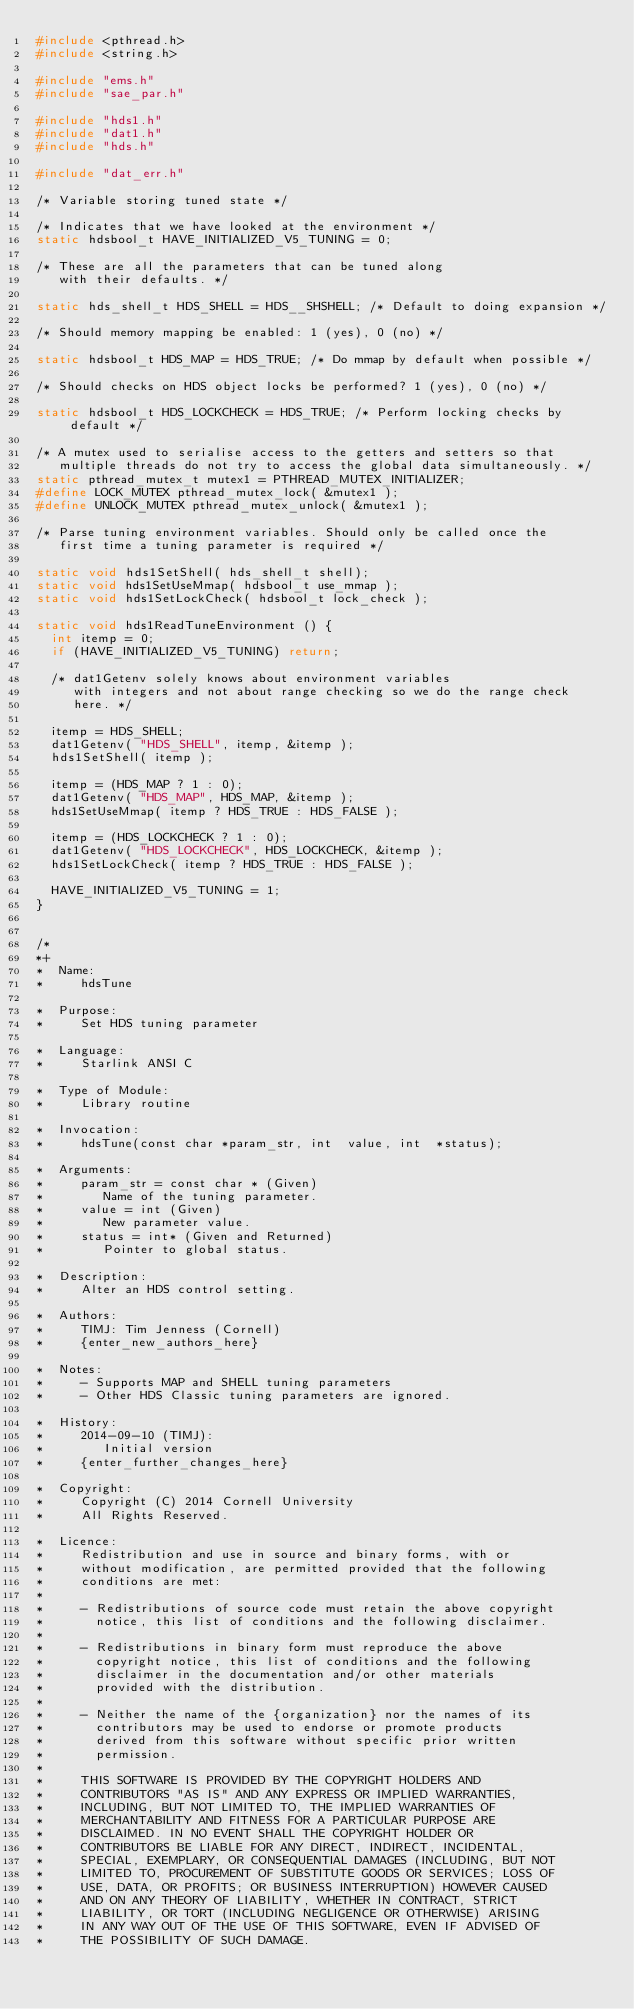Convert code to text. <code><loc_0><loc_0><loc_500><loc_500><_C_>#include <pthread.h>
#include <string.h>

#include "ems.h"
#include "sae_par.h"

#include "hds1.h"
#include "dat1.h"
#include "hds.h"

#include "dat_err.h"

/* Variable storing tuned state */

/* Indicates that we have looked at the environment */
static hdsbool_t HAVE_INITIALIZED_V5_TUNING = 0;

/* These are all the parameters that can be tuned along
   with their defaults. */

static hds_shell_t HDS_SHELL = HDS__SHSHELL; /* Default to doing expansion */

/* Should memory mapping be enabled: 1 (yes), 0 (no) */

static hdsbool_t HDS_MAP = HDS_TRUE; /* Do mmap by default when possible */

/* Should checks on HDS object locks be performed? 1 (yes), 0 (no) */

static hdsbool_t HDS_LOCKCHECK = HDS_TRUE; /* Perform locking checks by default */

/* A mutex used to serialise access to the getters and setters so that
   multiple threads do not try to access the global data simultaneously. */
static pthread_mutex_t mutex1 = PTHREAD_MUTEX_INITIALIZER;
#define LOCK_MUTEX pthread_mutex_lock( &mutex1 );
#define UNLOCK_MUTEX pthread_mutex_unlock( &mutex1 );

/* Parse tuning environment variables. Should only be called once the
   first time a tuning parameter is required */

static void hds1SetShell( hds_shell_t shell);
static void hds1SetUseMmap( hdsbool_t use_mmap );
static void hds1SetLockCheck( hdsbool_t lock_check );

static void hds1ReadTuneEnvironment () {
  int itemp = 0;
  if (HAVE_INITIALIZED_V5_TUNING) return;

  /* dat1Getenv solely knows about environment variables
     with integers and not about range checking so we do the range check
     here. */

  itemp = HDS_SHELL;
  dat1Getenv( "HDS_SHELL", itemp, &itemp );
  hds1SetShell( itemp );

  itemp = (HDS_MAP ? 1 : 0);
  dat1Getenv( "HDS_MAP", HDS_MAP, &itemp );
  hds1SetUseMmap( itemp ? HDS_TRUE : HDS_FALSE );

  itemp = (HDS_LOCKCHECK ? 1 : 0);
  dat1Getenv( "HDS_LOCKCHECK", HDS_LOCKCHECK, &itemp );
  hds1SetLockCheck( itemp ? HDS_TRUE : HDS_FALSE );

  HAVE_INITIALIZED_V5_TUNING = 1;
}


/*
*+
*  Name:
*     hdsTune

*  Purpose:
*     Set HDS tuning parameter

*  Language:
*     Starlink ANSI C

*  Type of Module:
*     Library routine

*  Invocation:
*     hdsTune(const char *param_str, int  value, int  *status);

*  Arguments:
*     param_str = const char * (Given)
*        Name of the tuning parameter.
*     value = int (Given)
*        New parameter value.
*     status = int* (Given and Returned)
*        Pointer to global status.

*  Description:
*     Alter an HDS control setting.

*  Authors:
*     TIMJ: Tim Jenness (Cornell)
*     {enter_new_authors_here}

*  Notes:
*     - Supports MAP and SHELL tuning parameters
*     - Other HDS Classic tuning parameters are ignored.

*  History:
*     2014-09-10 (TIMJ):
*        Initial version
*     {enter_further_changes_here}

*  Copyright:
*     Copyright (C) 2014 Cornell University
*     All Rights Reserved.

*  Licence:
*     Redistribution and use in source and binary forms, with or
*     without modification, are permitted provided that the following
*     conditions are met:
*
*     - Redistributions of source code must retain the above copyright
*       notice, this list of conditions and the following disclaimer.
*
*     - Redistributions in binary form must reproduce the above
*       copyright notice, this list of conditions and the following
*       disclaimer in the documentation and/or other materials
*       provided with the distribution.
*
*     - Neither the name of the {organization} nor the names of its
*       contributors may be used to endorse or promote products
*       derived from this software without specific prior written
*       permission.
*
*     THIS SOFTWARE IS PROVIDED BY THE COPYRIGHT HOLDERS AND
*     CONTRIBUTORS "AS IS" AND ANY EXPRESS OR IMPLIED WARRANTIES,
*     INCLUDING, BUT NOT LIMITED TO, THE IMPLIED WARRANTIES OF
*     MERCHANTABILITY AND FITNESS FOR A PARTICULAR PURPOSE ARE
*     DISCLAIMED. IN NO EVENT SHALL THE COPYRIGHT HOLDER OR
*     CONTRIBUTORS BE LIABLE FOR ANY DIRECT, INDIRECT, INCIDENTAL,
*     SPECIAL, EXEMPLARY, OR CONSEQUENTIAL DAMAGES (INCLUDING, BUT NOT
*     LIMITED TO, PROCUREMENT OF SUBSTITUTE GOODS OR SERVICES; LOSS OF
*     USE, DATA, OR PROFITS; OR BUSINESS INTERRUPTION) HOWEVER CAUSED
*     AND ON ANY THEORY OF LIABILITY, WHETHER IN CONTRACT, STRICT
*     LIABILITY, OR TORT (INCLUDING NEGLIGENCE OR OTHERWISE) ARISING
*     IN ANY WAY OUT OF THE USE OF THIS SOFTWARE, EVEN IF ADVISED OF
*     THE POSSIBILITY OF SUCH DAMAGE.
</code> 